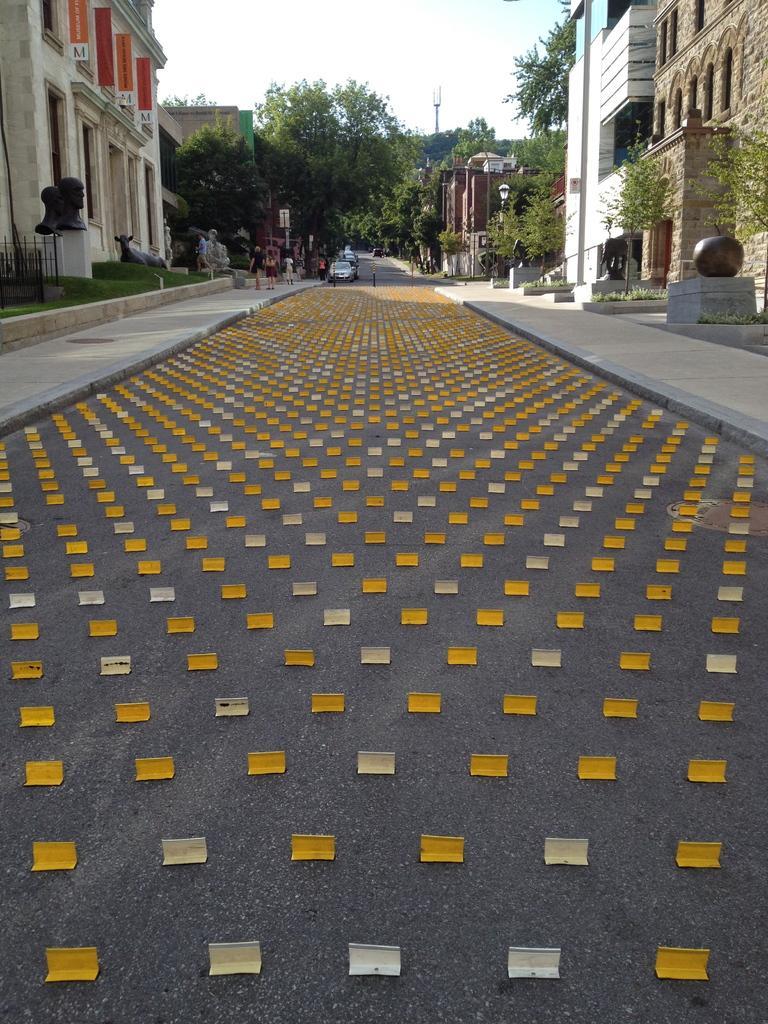Could you give a brief overview of what you see in this image? In this picture there is a road which has few objects placed on it and there are few buildings and trees on either sides of it and there are few people and vehicles in the background. 